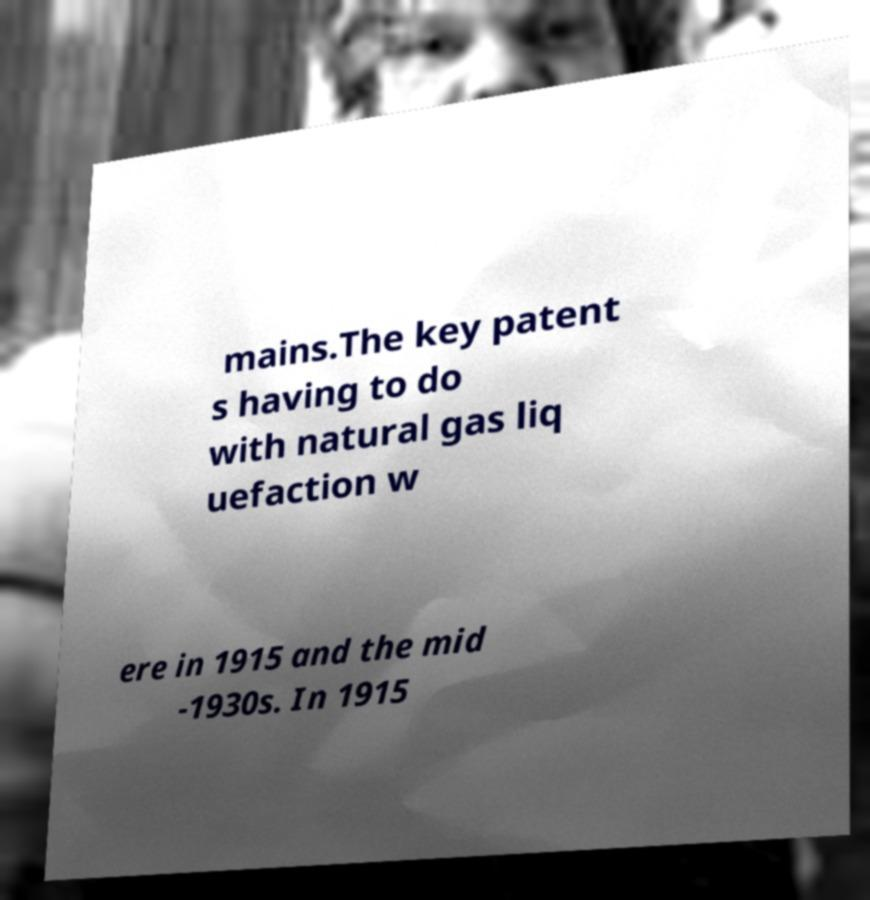There's text embedded in this image that I need extracted. Can you transcribe it verbatim? mains.The key patent s having to do with natural gas liq uefaction w ere in 1915 and the mid -1930s. In 1915 